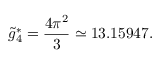<formula> <loc_0><loc_0><loc_500><loc_500>\tilde { g } _ { 4 } ^ { * } = \frac { 4 \pi ^ { 2 } } { 3 } \simeq 1 3 . 1 5 9 4 7 .</formula> 